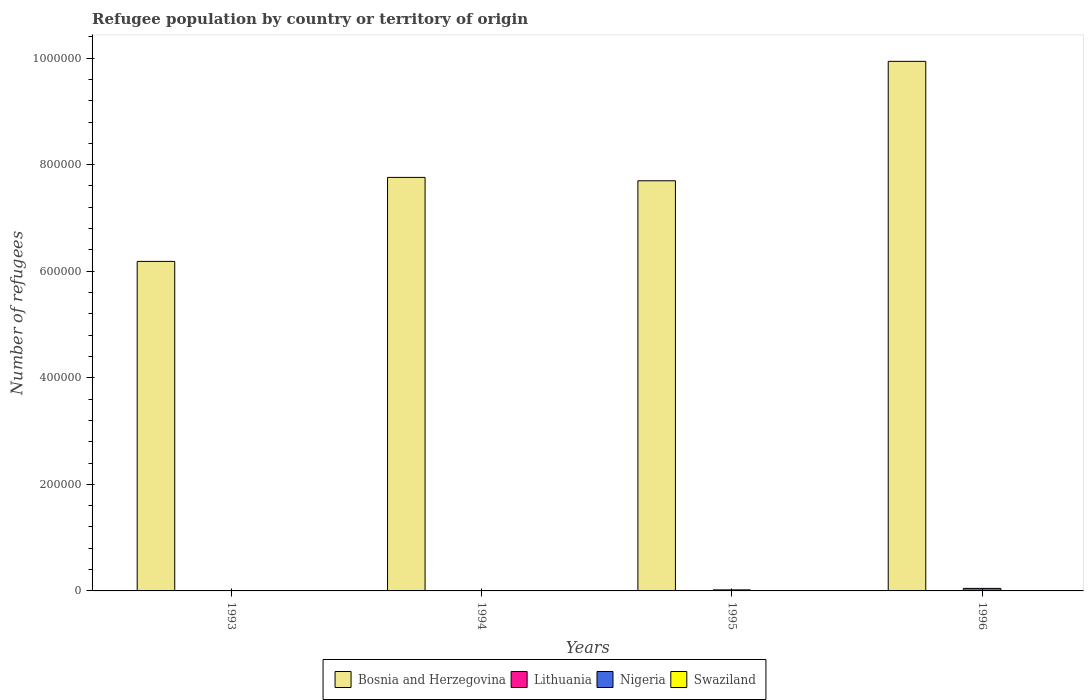How many groups of bars are there?
Offer a very short reply. 4. Are the number of bars per tick equal to the number of legend labels?
Give a very brief answer. Yes. In how many cases, is the number of bars for a given year not equal to the number of legend labels?
Give a very brief answer. 0. What is the number of refugees in Nigeria in 1994?
Your response must be concise. 592. Across all years, what is the maximum number of refugees in Lithuania?
Give a very brief answer. 662. Across all years, what is the minimum number of refugees in Lithuania?
Your response must be concise. 11. What is the total number of refugees in Lithuania in the graph?
Offer a terse response. 845. What is the difference between the number of refugees in Bosnia and Herzegovina in 1994 and that in 1995?
Keep it short and to the point. 6331. What is the difference between the number of refugees in Swaziland in 1993 and the number of refugees in Lithuania in 1995?
Ensure brevity in your answer.  -108. What is the average number of refugees in Lithuania per year?
Keep it short and to the point. 211.25. What is the ratio of the number of refugees in Swaziland in 1993 to that in 1995?
Offer a very short reply. 0.07. Is the number of refugees in Bosnia and Herzegovina in 1993 less than that in 1995?
Ensure brevity in your answer.  Yes. What is the difference between the highest and the second highest number of refugees in Bosnia and Herzegovina?
Provide a succinct answer. 2.18e+05. What is the difference between the highest and the lowest number of refugees in Nigeria?
Ensure brevity in your answer.  4654. In how many years, is the number of refugees in Swaziland greater than the average number of refugees in Swaziland taken over all years?
Ensure brevity in your answer.  3. Is the sum of the number of refugees in Swaziland in 1993 and 1994 greater than the maximum number of refugees in Nigeria across all years?
Give a very brief answer. No. What does the 3rd bar from the left in 1994 represents?
Your answer should be very brief. Nigeria. What does the 4th bar from the right in 1996 represents?
Keep it short and to the point. Bosnia and Herzegovina. How many years are there in the graph?
Your answer should be compact. 4. What is the difference between two consecutive major ticks on the Y-axis?
Offer a terse response. 2.00e+05. Are the values on the major ticks of Y-axis written in scientific E-notation?
Provide a succinct answer. No. What is the title of the graph?
Provide a short and direct response. Refugee population by country or territory of origin. What is the label or title of the X-axis?
Your answer should be compact. Years. What is the label or title of the Y-axis?
Provide a succinct answer. Number of refugees. What is the Number of refugees in Bosnia and Herzegovina in 1993?
Your answer should be compact. 6.18e+05. What is the Number of refugees of Bosnia and Herzegovina in 1994?
Give a very brief answer. 7.76e+05. What is the Number of refugees in Nigeria in 1994?
Your answer should be compact. 592. What is the Number of refugees in Swaziland in 1994?
Offer a terse response. 13. What is the Number of refugees of Bosnia and Herzegovina in 1995?
Make the answer very short. 7.70e+05. What is the Number of refugees of Lithuania in 1995?
Make the answer very short. 109. What is the Number of refugees of Nigeria in 1995?
Your answer should be compact. 1939. What is the Number of refugees of Bosnia and Herzegovina in 1996?
Provide a succinct answer. 9.94e+05. What is the Number of refugees of Lithuania in 1996?
Make the answer very short. 662. What is the Number of refugees in Nigeria in 1996?
Ensure brevity in your answer.  4754. What is the Number of refugees in Swaziland in 1996?
Your response must be concise. 17. Across all years, what is the maximum Number of refugees in Bosnia and Herzegovina?
Ensure brevity in your answer.  9.94e+05. Across all years, what is the maximum Number of refugees of Lithuania?
Your response must be concise. 662. Across all years, what is the maximum Number of refugees in Nigeria?
Provide a succinct answer. 4754. Across all years, what is the minimum Number of refugees in Bosnia and Herzegovina?
Ensure brevity in your answer.  6.18e+05. Across all years, what is the minimum Number of refugees in Nigeria?
Your answer should be compact. 100. What is the total Number of refugees in Bosnia and Herzegovina in the graph?
Ensure brevity in your answer.  3.16e+06. What is the total Number of refugees of Lithuania in the graph?
Give a very brief answer. 845. What is the total Number of refugees of Nigeria in the graph?
Give a very brief answer. 7385. What is the total Number of refugees in Swaziland in the graph?
Ensure brevity in your answer.  46. What is the difference between the Number of refugees in Bosnia and Herzegovina in 1993 and that in 1994?
Ensure brevity in your answer.  -1.58e+05. What is the difference between the Number of refugees in Lithuania in 1993 and that in 1994?
Your answer should be very brief. -52. What is the difference between the Number of refugees in Nigeria in 1993 and that in 1994?
Offer a terse response. -492. What is the difference between the Number of refugees of Bosnia and Herzegovina in 1993 and that in 1995?
Your response must be concise. -1.51e+05. What is the difference between the Number of refugees of Lithuania in 1993 and that in 1995?
Your answer should be very brief. -98. What is the difference between the Number of refugees in Nigeria in 1993 and that in 1995?
Keep it short and to the point. -1839. What is the difference between the Number of refugees of Bosnia and Herzegovina in 1993 and that in 1996?
Give a very brief answer. -3.75e+05. What is the difference between the Number of refugees in Lithuania in 1993 and that in 1996?
Give a very brief answer. -651. What is the difference between the Number of refugees in Nigeria in 1993 and that in 1996?
Keep it short and to the point. -4654. What is the difference between the Number of refugees in Bosnia and Herzegovina in 1994 and that in 1995?
Ensure brevity in your answer.  6331. What is the difference between the Number of refugees in Lithuania in 1994 and that in 1995?
Provide a short and direct response. -46. What is the difference between the Number of refugees in Nigeria in 1994 and that in 1995?
Your response must be concise. -1347. What is the difference between the Number of refugees of Swaziland in 1994 and that in 1995?
Give a very brief answer. -2. What is the difference between the Number of refugees of Bosnia and Herzegovina in 1994 and that in 1996?
Ensure brevity in your answer.  -2.18e+05. What is the difference between the Number of refugees of Lithuania in 1994 and that in 1996?
Make the answer very short. -599. What is the difference between the Number of refugees in Nigeria in 1994 and that in 1996?
Give a very brief answer. -4162. What is the difference between the Number of refugees in Swaziland in 1994 and that in 1996?
Ensure brevity in your answer.  -4. What is the difference between the Number of refugees of Bosnia and Herzegovina in 1995 and that in 1996?
Provide a short and direct response. -2.24e+05. What is the difference between the Number of refugees in Lithuania in 1995 and that in 1996?
Your answer should be very brief. -553. What is the difference between the Number of refugees of Nigeria in 1995 and that in 1996?
Provide a short and direct response. -2815. What is the difference between the Number of refugees of Bosnia and Herzegovina in 1993 and the Number of refugees of Lithuania in 1994?
Provide a succinct answer. 6.18e+05. What is the difference between the Number of refugees in Bosnia and Herzegovina in 1993 and the Number of refugees in Nigeria in 1994?
Your response must be concise. 6.18e+05. What is the difference between the Number of refugees in Bosnia and Herzegovina in 1993 and the Number of refugees in Swaziland in 1994?
Provide a succinct answer. 6.18e+05. What is the difference between the Number of refugees in Lithuania in 1993 and the Number of refugees in Nigeria in 1994?
Keep it short and to the point. -581. What is the difference between the Number of refugees in Bosnia and Herzegovina in 1993 and the Number of refugees in Lithuania in 1995?
Provide a succinct answer. 6.18e+05. What is the difference between the Number of refugees of Bosnia and Herzegovina in 1993 and the Number of refugees of Nigeria in 1995?
Offer a very short reply. 6.16e+05. What is the difference between the Number of refugees of Bosnia and Herzegovina in 1993 and the Number of refugees of Swaziland in 1995?
Your answer should be very brief. 6.18e+05. What is the difference between the Number of refugees of Lithuania in 1993 and the Number of refugees of Nigeria in 1995?
Your response must be concise. -1928. What is the difference between the Number of refugees of Lithuania in 1993 and the Number of refugees of Swaziland in 1995?
Provide a short and direct response. -4. What is the difference between the Number of refugees of Bosnia and Herzegovina in 1993 and the Number of refugees of Lithuania in 1996?
Your answer should be very brief. 6.18e+05. What is the difference between the Number of refugees of Bosnia and Herzegovina in 1993 and the Number of refugees of Nigeria in 1996?
Provide a short and direct response. 6.14e+05. What is the difference between the Number of refugees in Bosnia and Herzegovina in 1993 and the Number of refugees in Swaziland in 1996?
Your answer should be compact. 6.18e+05. What is the difference between the Number of refugees of Lithuania in 1993 and the Number of refugees of Nigeria in 1996?
Make the answer very short. -4743. What is the difference between the Number of refugees of Bosnia and Herzegovina in 1994 and the Number of refugees of Lithuania in 1995?
Keep it short and to the point. 7.76e+05. What is the difference between the Number of refugees in Bosnia and Herzegovina in 1994 and the Number of refugees in Nigeria in 1995?
Your answer should be compact. 7.74e+05. What is the difference between the Number of refugees of Bosnia and Herzegovina in 1994 and the Number of refugees of Swaziland in 1995?
Keep it short and to the point. 7.76e+05. What is the difference between the Number of refugees in Lithuania in 1994 and the Number of refugees in Nigeria in 1995?
Give a very brief answer. -1876. What is the difference between the Number of refugees of Lithuania in 1994 and the Number of refugees of Swaziland in 1995?
Make the answer very short. 48. What is the difference between the Number of refugees in Nigeria in 1994 and the Number of refugees in Swaziland in 1995?
Make the answer very short. 577. What is the difference between the Number of refugees in Bosnia and Herzegovina in 1994 and the Number of refugees in Lithuania in 1996?
Your answer should be compact. 7.75e+05. What is the difference between the Number of refugees of Bosnia and Herzegovina in 1994 and the Number of refugees of Nigeria in 1996?
Provide a short and direct response. 7.71e+05. What is the difference between the Number of refugees of Bosnia and Herzegovina in 1994 and the Number of refugees of Swaziland in 1996?
Offer a very short reply. 7.76e+05. What is the difference between the Number of refugees in Lithuania in 1994 and the Number of refugees in Nigeria in 1996?
Offer a very short reply. -4691. What is the difference between the Number of refugees in Nigeria in 1994 and the Number of refugees in Swaziland in 1996?
Give a very brief answer. 575. What is the difference between the Number of refugees in Bosnia and Herzegovina in 1995 and the Number of refugees in Lithuania in 1996?
Your response must be concise. 7.69e+05. What is the difference between the Number of refugees of Bosnia and Herzegovina in 1995 and the Number of refugees of Nigeria in 1996?
Make the answer very short. 7.65e+05. What is the difference between the Number of refugees in Bosnia and Herzegovina in 1995 and the Number of refugees in Swaziland in 1996?
Offer a terse response. 7.70e+05. What is the difference between the Number of refugees in Lithuania in 1995 and the Number of refugees in Nigeria in 1996?
Keep it short and to the point. -4645. What is the difference between the Number of refugees in Lithuania in 1995 and the Number of refugees in Swaziland in 1996?
Your response must be concise. 92. What is the difference between the Number of refugees of Nigeria in 1995 and the Number of refugees of Swaziland in 1996?
Offer a terse response. 1922. What is the average Number of refugees in Bosnia and Herzegovina per year?
Make the answer very short. 7.90e+05. What is the average Number of refugees of Lithuania per year?
Make the answer very short. 211.25. What is the average Number of refugees in Nigeria per year?
Provide a succinct answer. 1846.25. What is the average Number of refugees in Swaziland per year?
Offer a very short reply. 11.5. In the year 1993, what is the difference between the Number of refugees in Bosnia and Herzegovina and Number of refugees in Lithuania?
Provide a succinct answer. 6.18e+05. In the year 1993, what is the difference between the Number of refugees in Bosnia and Herzegovina and Number of refugees in Nigeria?
Offer a terse response. 6.18e+05. In the year 1993, what is the difference between the Number of refugees of Bosnia and Herzegovina and Number of refugees of Swaziland?
Your response must be concise. 6.18e+05. In the year 1993, what is the difference between the Number of refugees in Lithuania and Number of refugees in Nigeria?
Offer a terse response. -89. In the year 1993, what is the difference between the Number of refugees in Lithuania and Number of refugees in Swaziland?
Give a very brief answer. 10. In the year 1993, what is the difference between the Number of refugees of Nigeria and Number of refugees of Swaziland?
Ensure brevity in your answer.  99. In the year 1994, what is the difference between the Number of refugees in Bosnia and Herzegovina and Number of refugees in Lithuania?
Your response must be concise. 7.76e+05. In the year 1994, what is the difference between the Number of refugees in Bosnia and Herzegovina and Number of refugees in Nigeria?
Your response must be concise. 7.75e+05. In the year 1994, what is the difference between the Number of refugees in Bosnia and Herzegovina and Number of refugees in Swaziland?
Your answer should be very brief. 7.76e+05. In the year 1994, what is the difference between the Number of refugees of Lithuania and Number of refugees of Nigeria?
Provide a short and direct response. -529. In the year 1994, what is the difference between the Number of refugees of Lithuania and Number of refugees of Swaziland?
Your answer should be very brief. 50. In the year 1994, what is the difference between the Number of refugees in Nigeria and Number of refugees in Swaziland?
Your response must be concise. 579. In the year 1995, what is the difference between the Number of refugees in Bosnia and Herzegovina and Number of refugees in Lithuania?
Your response must be concise. 7.70e+05. In the year 1995, what is the difference between the Number of refugees in Bosnia and Herzegovina and Number of refugees in Nigeria?
Your answer should be very brief. 7.68e+05. In the year 1995, what is the difference between the Number of refugees in Bosnia and Herzegovina and Number of refugees in Swaziland?
Ensure brevity in your answer.  7.70e+05. In the year 1995, what is the difference between the Number of refugees in Lithuania and Number of refugees in Nigeria?
Offer a terse response. -1830. In the year 1995, what is the difference between the Number of refugees of Lithuania and Number of refugees of Swaziland?
Your answer should be very brief. 94. In the year 1995, what is the difference between the Number of refugees in Nigeria and Number of refugees in Swaziland?
Make the answer very short. 1924. In the year 1996, what is the difference between the Number of refugees of Bosnia and Herzegovina and Number of refugees of Lithuania?
Make the answer very short. 9.93e+05. In the year 1996, what is the difference between the Number of refugees in Bosnia and Herzegovina and Number of refugees in Nigeria?
Your answer should be compact. 9.89e+05. In the year 1996, what is the difference between the Number of refugees of Bosnia and Herzegovina and Number of refugees of Swaziland?
Offer a very short reply. 9.94e+05. In the year 1996, what is the difference between the Number of refugees in Lithuania and Number of refugees in Nigeria?
Ensure brevity in your answer.  -4092. In the year 1996, what is the difference between the Number of refugees in Lithuania and Number of refugees in Swaziland?
Keep it short and to the point. 645. In the year 1996, what is the difference between the Number of refugees in Nigeria and Number of refugees in Swaziland?
Your response must be concise. 4737. What is the ratio of the Number of refugees of Bosnia and Herzegovina in 1993 to that in 1994?
Your response must be concise. 0.8. What is the ratio of the Number of refugees in Lithuania in 1993 to that in 1994?
Offer a terse response. 0.17. What is the ratio of the Number of refugees in Nigeria in 1993 to that in 1994?
Make the answer very short. 0.17. What is the ratio of the Number of refugees in Swaziland in 1993 to that in 1994?
Keep it short and to the point. 0.08. What is the ratio of the Number of refugees of Bosnia and Herzegovina in 1993 to that in 1995?
Make the answer very short. 0.8. What is the ratio of the Number of refugees in Lithuania in 1993 to that in 1995?
Give a very brief answer. 0.1. What is the ratio of the Number of refugees in Nigeria in 1993 to that in 1995?
Your response must be concise. 0.05. What is the ratio of the Number of refugees of Swaziland in 1993 to that in 1995?
Make the answer very short. 0.07. What is the ratio of the Number of refugees of Bosnia and Herzegovina in 1993 to that in 1996?
Offer a very short reply. 0.62. What is the ratio of the Number of refugees in Lithuania in 1993 to that in 1996?
Offer a very short reply. 0.02. What is the ratio of the Number of refugees of Nigeria in 1993 to that in 1996?
Make the answer very short. 0.02. What is the ratio of the Number of refugees in Swaziland in 1993 to that in 1996?
Make the answer very short. 0.06. What is the ratio of the Number of refugees in Bosnia and Herzegovina in 1994 to that in 1995?
Your answer should be compact. 1.01. What is the ratio of the Number of refugees of Lithuania in 1994 to that in 1995?
Give a very brief answer. 0.58. What is the ratio of the Number of refugees in Nigeria in 1994 to that in 1995?
Ensure brevity in your answer.  0.31. What is the ratio of the Number of refugees in Swaziland in 1994 to that in 1995?
Provide a succinct answer. 0.87. What is the ratio of the Number of refugees of Bosnia and Herzegovina in 1994 to that in 1996?
Make the answer very short. 0.78. What is the ratio of the Number of refugees in Lithuania in 1994 to that in 1996?
Make the answer very short. 0.1. What is the ratio of the Number of refugees of Nigeria in 1994 to that in 1996?
Ensure brevity in your answer.  0.12. What is the ratio of the Number of refugees of Swaziland in 1994 to that in 1996?
Provide a succinct answer. 0.76. What is the ratio of the Number of refugees in Bosnia and Herzegovina in 1995 to that in 1996?
Give a very brief answer. 0.77. What is the ratio of the Number of refugees in Lithuania in 1995 to that in 1996?
Give a very brief answer. 0.16. What is the ratio of the Number of refugees in Nigeria in 1995 to that in 1996?
Provide a succinct answer. 0.41. What is the ratio of the Number of refugees of Swaziland in 1995 to that in 1996?
Offer a terse response. 0.88. What is the difference between the highest and the second highest Number of refugees in Bosnia and Herzegovina?
Give a very brief answer. 2.18e+05. What is the difference between the highest and the second highest Number of refugees in Lithuania?
Ensure brevity in your answer.  553. What is the difference between the highest and the second highest Number of refugees in Nigeria?
Give a very brief answer. 2815. What is the difference between the highest and the lowest Number of refugees of Bosnia and Herzegovina?
Offer a very short reply. 3.75e+05. What is the difference between the highest and the lowest Number of refugees of Lithuania?
Keep it short and to the point. 651. What is the difference between the highest and the lowest Number of refugees in Nigeria?
Offer a terse response. 4654. What is the difference between the highest and the lowest Number of refugees in Swaziland?
Offer a very short reply. 16. 